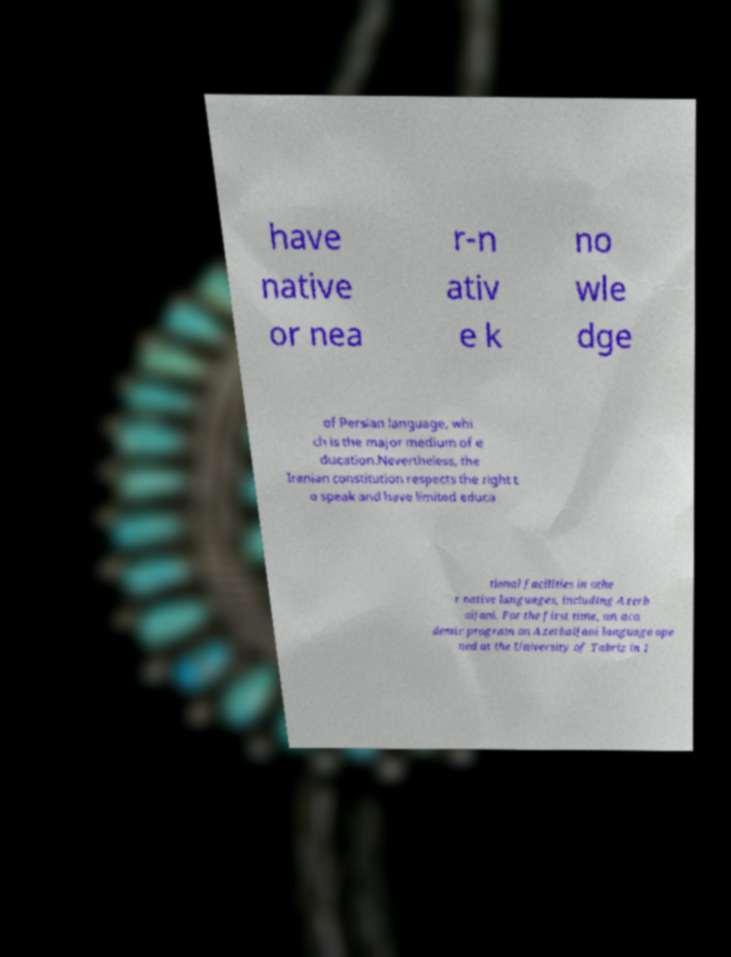For documentation purposes, I need the text within this image transcribed. Could you provide that? have native or nea r-n ativ e k no wle dge of Persian language, whi ch is the major medium of e ducation.Nevertheless, the Iranian constitution respects the right t o speak and have limited educa tional facilities in othe r native languages, including Azerb aijani. For the first time, an aca demic program on Azerbaijani language ope ned at the University of Tabriz in 1 